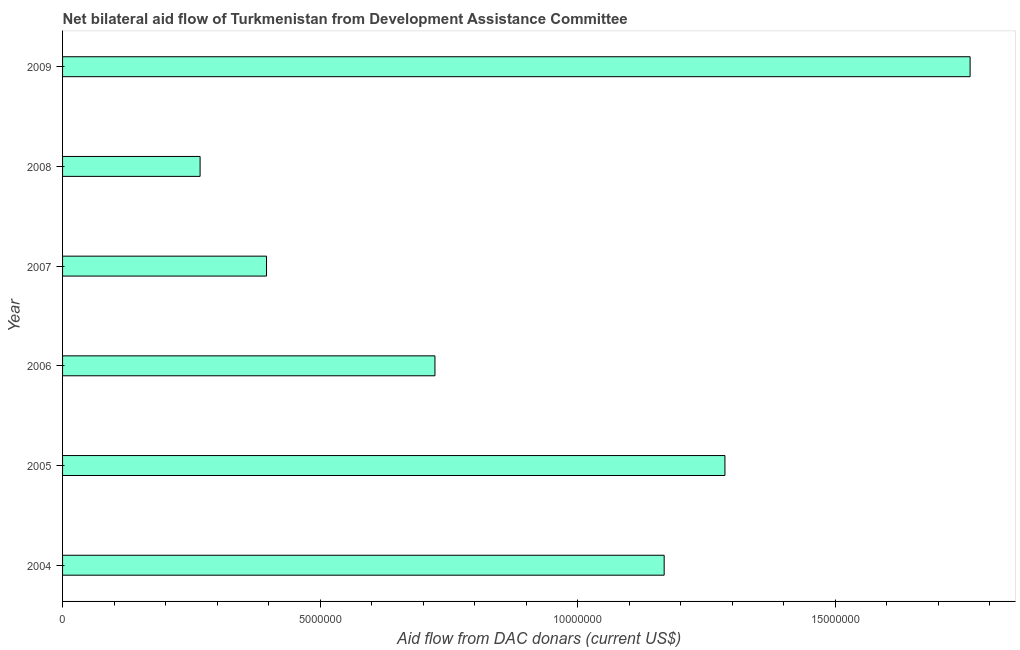Does the graph contain any zero values?
Make the answer very short. No. What is the title of the graph?
Offer a very short reply. Net bilateral aid flow of Turkmenistan from Development Assistance Committee. What is the label or title of the X-axis?
Provide a short and direct response. Aid flow from DAC donars (current US$). What is the label or title of the Y-axis?
Keep it short and to the point. Year. What is the net bilateral aid flows from dac donors in 2005?
Your answer should be compact. 1.29e+07. Across all years, what is the maximum net bilateral aid flows from dac donors?
Offer a very short reply. 1.76e+07. Across all years, what is the minimum net bilateral aid flows from dac donors?
Your answer should be very brief. 2.67e+06. In which year was the net bilateral aid flows from dac donors maximum?
Offer a very short reply. 2009. What is the sum of the net bilateral aid flows from dac donors?
Your response must be concise. 5.60e+07. What is the difference between the net bilateral aid flows from dac donors in 2007 and 2008?
Offer a very short reply. 1.29e+06. What is the average net bilateral aid flows from dac donors per year?
Ensure brevity in your answer.  9.34e+06. What is the median net bilateral aid flows from dac donors?
Your answer should be compact. 9.46e+06. In how many years, is the net bilateral aid flows from dac donors greater than 10000000 US$?
Your answer should be compact. 3. What is the ratio of the net bilateral aid flows from dac donors in 2008 to that in 2009?
Your answer should be very brief. 0.15. Is the net bilateral aid flows from dac donors in 2006 less than that in 2008?
Make the answer very short. No. Is the difference between the net bilateral aid flows from dac donors in 2004 and 2009 greater than the difference between any two years?
Give a very brief answer. No. What is the difference between the highest and the second highest net bilateral aid flows from dac donors?
Provide a succinct answer. 4.76e+06. What is the difference between the highest and the lowest net bilateral aid flows from dac donors?
Ensure brevity in your answer.  1.50e+07. Are all the bars in the graph horizontal?
Your answer should be compact. Yes. What is the difference between two consecutive major ticks on the X-axis?
Give a very brief answer. 5.00e+06. What is the Aid flow from DAC donars (current US$) of 2004?
Make the answer very short. 1.17e+07. What is the Aid flow from DAC donars (current US$) of 2005?
Your answer should be very brief. 1.29e+07. What is the Aid flow from DAC donars (current US$) of 2006?
Keep it short and to the point. 7.23e+06. What is the Aid flow from DAC donars (current US$) in 2007?
Your response must be concise. 3.96e+06. What is the Aid flow from DAC donars (current US$) in 2008?
Make the answer very short. 2.67e+06. What is the Aid flow from DAC donars (current US$) of 2009?
Your response must be concise. 1.76e+07. What is the difference between the Aid flow from DAC donars (current US$) in 2004 and 2005?
Keep it short and to the point. -1.18e+06. What is the difference between the Aid flow from DAC donars (current US$) in 2004 and 2006?
Keep it short and to the point. 4.45e+06. What is the difference between the Aid flow from DAC donars (current US$) in 2004 and 2007?
Offer a terse response. 7.72e+06. What is the difference between the Aid flow from DAC donars (current US$) in 2004 and 2008?
Your answer should be very brief. 9.01e+06. What is the difference between the Aid flow from DAC donars (current US$) in 2004 and 2009?
Ensure brevity in your answer.  -5.94e+06. What is the difference between the Aid flow from DAC donars (current US$) in 2005 and 2006?
Your answer should be very brief. 5.63e+06. What is the difference between the Aid flow from DAC donars (current US$) in 2005 and 2007?
Provide a succinct answer. 8.90e+06. What is the difference between the Aid flow from DAC donars (current US$) in 2005 and 2008?
Provide a succinct answer. 1.02e+07. What is the difference between the Aid flow from DAC donars (current US$) in 2005 and 2009?
Keep it short and to the point. -4.76e+06. What is the difference between the Aid flow from DAC donars (current US$) in 2006 and 2007?
Make the answer very short. 3.27e+06. What is the difference between the Aid flow from DAC donars (current US$) in 2006 and 2008?
Your answer should be compact. 4.56e+06. What is the difference between the Aid flow from DAC donars (current US$) in 2006 and 2009?
Offer a terse response. -1.04e+07. What is the difference between the Aid flow from DAC donars (current US$) in 2007 and 2008?
Provide a succinct answer. 1.29e+06. What is the difference between the Aid flow from DAC donars (current US$) in 2007 and 2009?
Your response must be concise. -1.37e+07. What is the difference between the Aid flow from DAC donars (current US$) in 2008 and 2009?
Give a very brief answer. -1.50e+07. What is the ratio of the Aid flow from DAC donars (current US$) in 2004 to that in 2005?
Keep it short and to the point. 0.91. What is the ratio of the Aid flow from DAC donars (current US$) in 2004 to that in 2006?
Offer a terse response. 1.61. What is the ratio of the Aid flow from DAC donars (current US$) in 2004 to that in 2007?
Keep it short and to the point. 2.95. What is the ratio of the Aid flow from DAC donars (current US$) in 2004 to that in 2008?
Offer a very short reply. 4.38. What is the ratio of the Aid flow from DAC donars (current US$) in 2004 to that in 2009?
Keep it short and to the point. 0.66. What is the ratio of the Aid flow from DAC donars (current US$) in 2005 to that in 2006?
Your answer should be very brief. 1.78. What is the ratio of the Aid flow from DAC donars (current US$) in 2005 to that in 2007?
Your response must be concise. 3.25. What is the ratio of the Aid flow from DAC donars (current US$) in 2005 to that in 2008?
Your answer should be very brief. 4.82. What is the ratio of the Aid flow from DAC donars (current US$) in 2005 to that in 2009?
Your answer should be compact. 0.73. What is the ratio of the Aid flow from DAC donars (current US$) in 2006 to that in 2007?
Your answer should be very brief. 1.83. What is the ratio of the Aid flow from DAC donars (current US$) in 2006 to that in 2008?
Provide a succinct answer. 2.71. What is the ratio of the Aid flow from DAC donars (current US$) in 2006 to that in 2009?
Your answer should be very brief. 0.41. What is the ratio of the Aid flow from DAC donars (current US$) in 2007 to that in 2008?
Keep it short and to the point. 1.48. What is the ratio of the Aid flow from DAC donars (current US$) in 2007 to that in 2009?
Your response must be concise. 0.23. What is the ratio of the Aid flow from DAC donars (current US$) in 2008 to that in 2009?
Your answer should be compact. 0.15. 